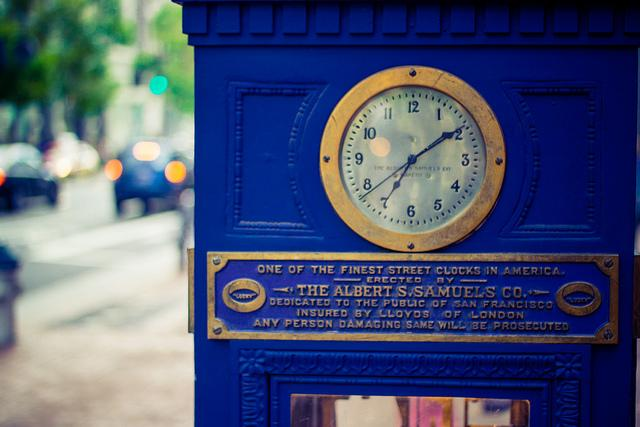In which metropolitan area is this clock installed? san francisco 